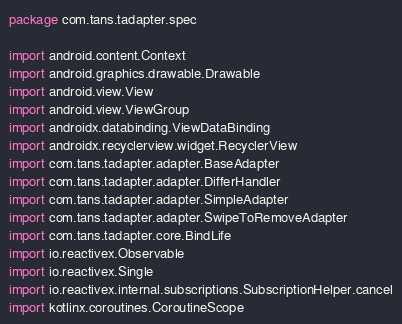<code> <loc_0><loc_0><loc_500><loc_500><_Kotlin_>package com.tans.tadapter.spec

import android.content.Context
import android.graphics.drawable.Drawable
import android.view.View
import android.view.ViewGroup
import androidx.databinding.ViewDataBinding
import androidx.recyclerview.widget.RecyclerView
import com.tans.tadapter.adapter.BaseAdapter
import com.tans.tadapter.adapter.DifferHandler
import com.tans.tadapter.adapter.SimpleAdapter
import com.tans.tadapter.adapter.SwipeToRemoveAdapter
import com.tans.tadapter.core.BindLife
import io.reactivex.Observable
import io.reactivex.Single
import io.reactivex.internal.subscriptions.SubscriptionHelper.cancel
import kotlinx.coroutines.CoroutineScope</code> 